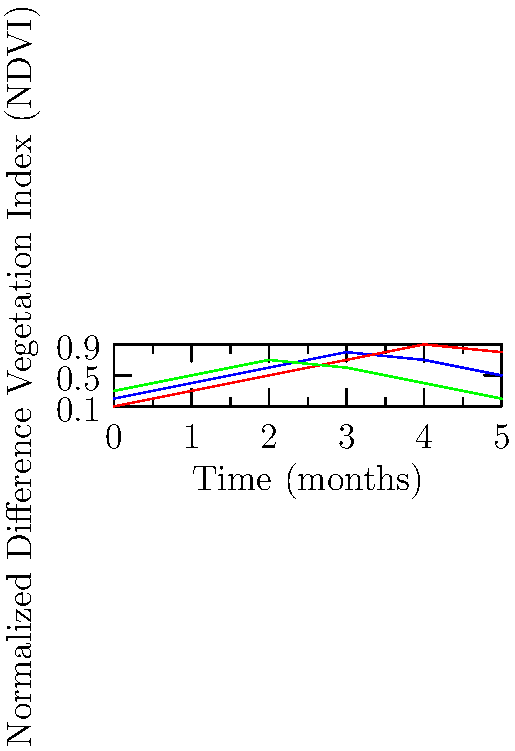Based on the satellite imagery-derived Normalized Difference Vegetation Index (NDVI) time series shown in the graph, which crop type exhibits the highest peak NDVI value and at what approximate time does this occur? To answer this question, we need to analyze the NDVI time series for each crop type:

1. Wheat (blue line):
   - Peak NDVI: approximately 0.8
   - Peak time: around 3 months

2. Corn (red line):
   - Peak NDVI: approximately 0.9
   - Peak time: around 4 months

3. Rice (green line):
   - Peak NDVI: approximately 0.7
   - Peak time: around 2-3 months

Comparing the peak NDVI values:
- Wheat: 0.8
- Corn: 0.9
- Rice: 0.7

Corn has the highest peak NDVI value of approximately 0.9, occurring at around 4 months.

This pattern is consistent with typical crop growth cycles:
- Corn often has a higher biomass and leaf area index at its peak growth stage compared to wheat and rice, resulting in a higher NDVI value.
- The longer time to reach peak NDVI for corn (4 months) aligns with its longer growing season compared to wheat and rice.

Understanding these temporal patterns in NDVI is crucial for crop type identification using satellite imagery, as it allows anthropologists to study agricultural practices and their impact on human civilization across different regions and time periods.
Answer: Corn, at approximately 4 months 